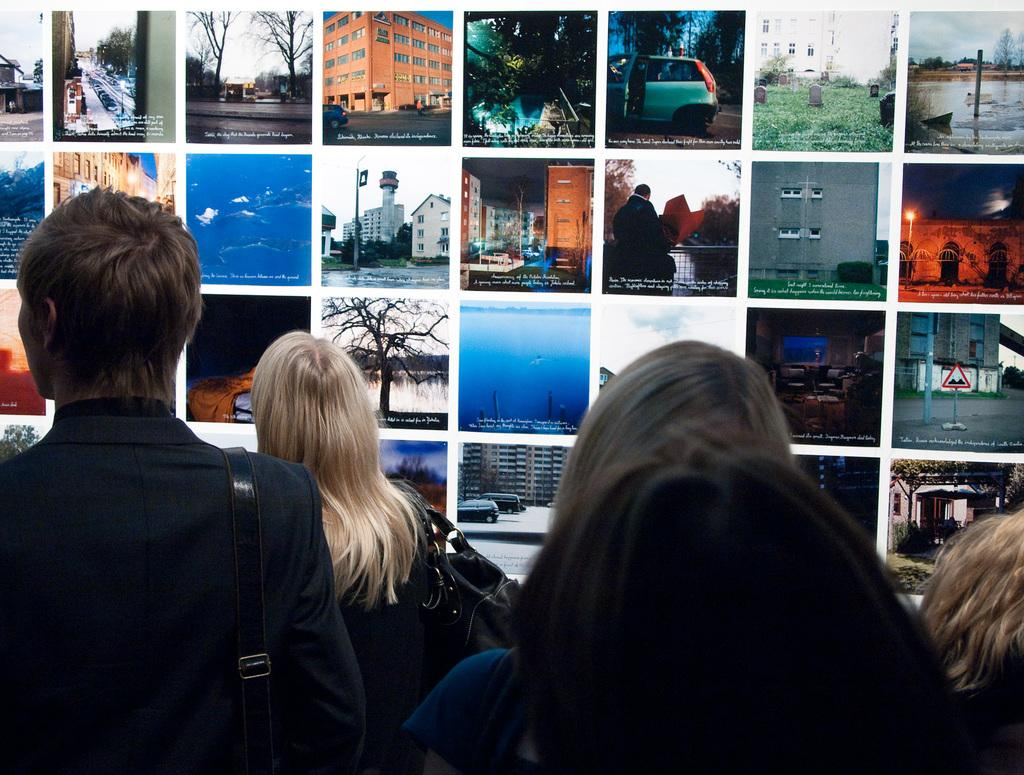What is the main subject of the image? The main subject of the image is a group of women. What are the women doing in the image? The women are standing in the image. What can be seen in the background of the image? There is a wall in the image, and photographs are pasted on the wall. What type of discussion is taking place among the women in the image? There is no indication of a discussion taking place among the women in the image. 